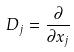<formula> <loc_0><loc_0><loc_500><loc_500>D _ { j } = \frac { \partial } { \partial x _ { j } }</formula> 